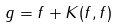Convert formula to latex. <formula><loc_0><loc_0><loc_500><loc_500>g = f + K ( f , f )</formula> 